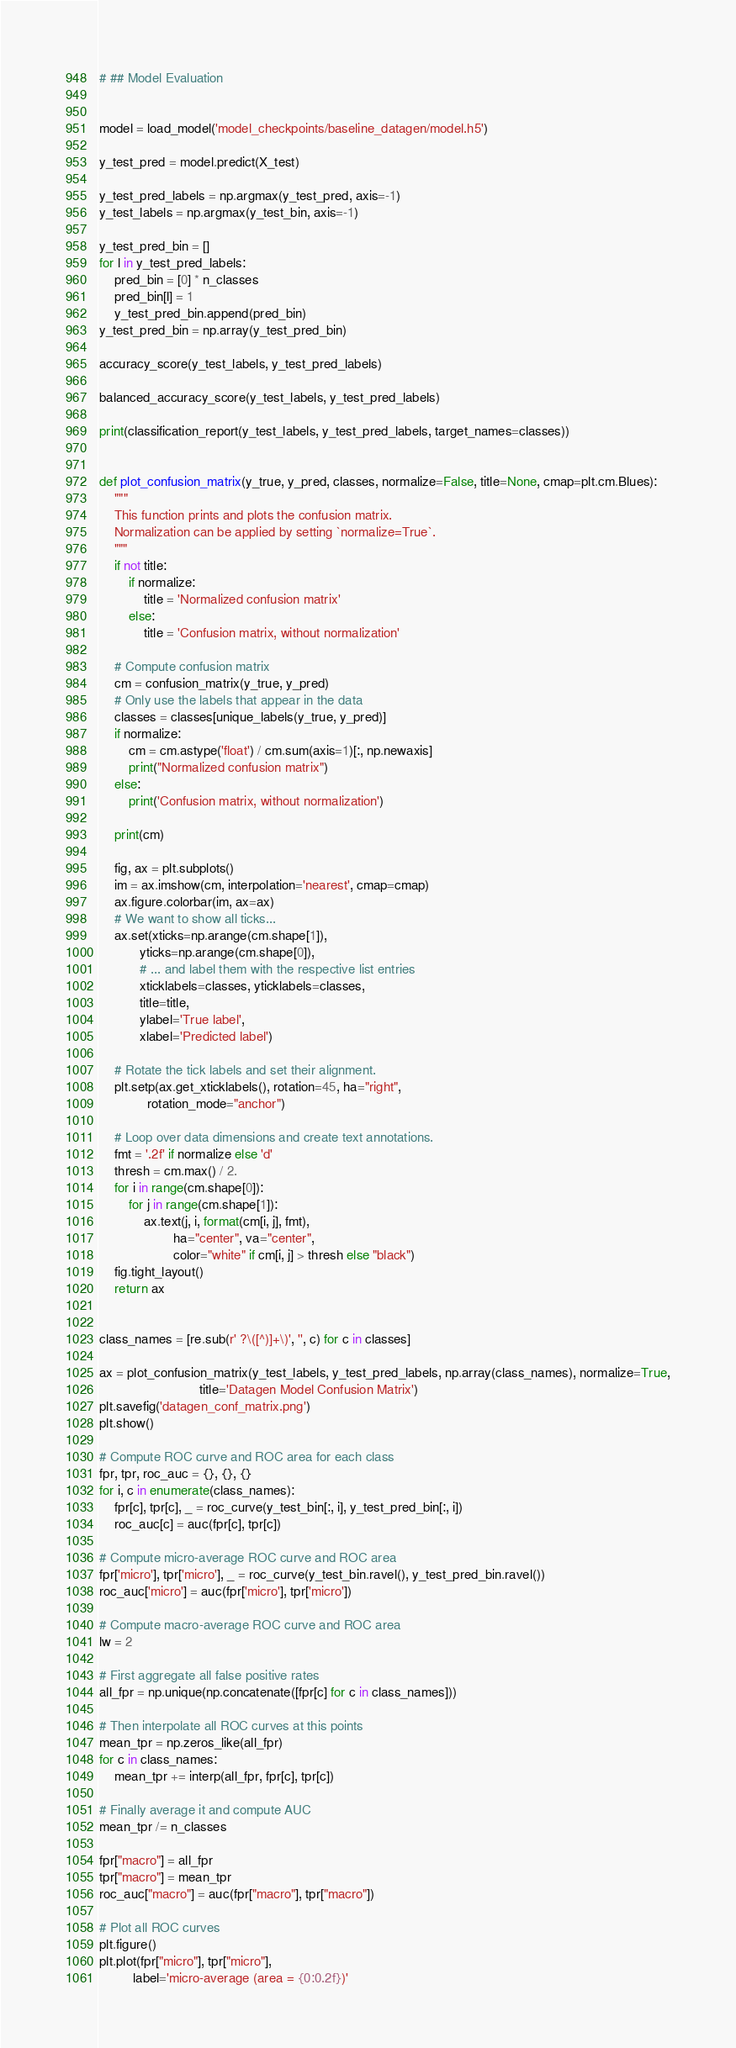<code> <loc_0><loc_0><loc_500><loc_500><_Python_># ## Model Evaluation 


model = load_model('model_checkpoints/baseline_datagen/model.h5')

y_test_pred = model.predict(X_test)

y_test_pred_labels = np.argmax(y_test_pred, axis=-1)
y_test_labels = np.argmax(y_test_bin, axis=-1)

y_test_pred_bin = []
for l in y_test_pred_labels:
    pred_bin = [0] * n_classes
    pred_bin[l] = 1
    y_test_pred_bin.append(pred_bin)
y_test_pred_bin = np.array(y_test_pred_bin)

accuracy_score(y_test_labels, y_test_pred_labels)

balanced_accuracy_score(y_test_labels, y_test_pred_labels)

print(classification_report(y_test_labels, y_test_pred_labels, target_names=classes))


def plot_confusion_matrix(y_true, y_pred, classes, normalize=False, title=None, cmap=plt.cm.Blues):
    """
    This function prints and plots the confusion matrix.
    Normalization can be applied by setting `normalize=True`.
    """
    if not title:
        if normalize:
            title = 'Normalized confusion matrix'
        else:
            title = 'Confusion matrix, without normalization'

    # Compute confusion matrix
    cm = confusion_matrix(y_true, y_pred)
    # Only use the labels that appear in the data
    classes = classes[unique_labels(y_true, y_pred)]
    if normalize:
        cm = cm.astype('float') / cm.sum(axis=1)[:, np.newaxis]
        print("Normalized confusion matrix")
    else:
        print('Confusion matrix, without normalization')

    print(cm)

    fig, ax = plt.subplots()
    im = ax.imshow(cm, interpolation='nearest', cmap=cmap)
    ax.figure.colorbar(im, ax=ax)
    # We want to show all ticks...
    ax.set(xticks=np.arange(cm.shape[1]),
           yticks=np.arange(cm.shape[0]),
           # ... and label them with the respective list entries
           xticklabels=classes, yticklabels=classes,
           title=title,
           ylabel='True label',
           xlabel='Predicted label')

    # Rotate the tick labels and set their alignment.
    plt.setp(ax.get_xticklabels(), rotation=45, ha="right",
             rotation_mode="anchor")

    # Loop over data dimensions and create text annotations.
    fmt = '.2f' if normalize else 'd'
    thresh = cm.max() / 2.
    for i in range(cm.shape[0]):
        for j in range(cm.shape[1]):
            ax.text(j, i, format(cm[i, j], fmt),
                    ha="center", va="center",
                    color="white" if cm[i, j] > thresh else "black")
    fig.tight_layout()
    return ax


class_names = [re.sub(r' ?\([^)]+\)', '', c) for c in classes]

ax = plot_confusion_matrix(y_test_labels, y_test_pred_labels, np.array(class_names), normalize=True,
                           title='Datagen Model Confusion Matrix')
plt.savefig('datagen_conf_matrix.png')
plt.show()

# Compute ROC curve and ROC area for each class
fpr, tpr, roc_auc = {}, {}, {}
for i, c in enumerate(class_names):
    fpr[c], tpr[c], _ = roc_curve(y_test_bin[:, i], y_test_pred_bin[:, i])
    roc_auc[c] = auc(fpr[c], tpr[c])

# Compute micro-average ROC curve and ROC area
fpr['micro'], tpr['micro'], _ = roc_curve(y_test_bin.ravel(), y_test_pred_bin.ravel())
roc_auc['micro'] = auc(fpr['micro'], tpr['micro'])

# Compute macro-average ROC curve and ROC area
lw = 2

# First aggregate all false positive rates
all_fpr = np.unique(np.concatenate([fpr[c] for c in class_names]))

# Then interpolate all ROC curves at this points
mean_tpr = np.zeros_like(all_fpr)
for c in class_names:
    mean_tpr += interp(all_fpr, fpr[c], tpr[c])

# Finally average it and compute AUC
mean_tpr /= n_classes

fpr["macro"] = all_fpr
tpr["macro"] = mean_tpr
roc_auc["macro"] = auc(fpr["macro"], tpr["macro"])

# Plot all ROC curves
plt.figure()
plt.plot(fpr["micro"], tpr["micro"],
         label='micro-average (area = {0:0.2f})'</code> 